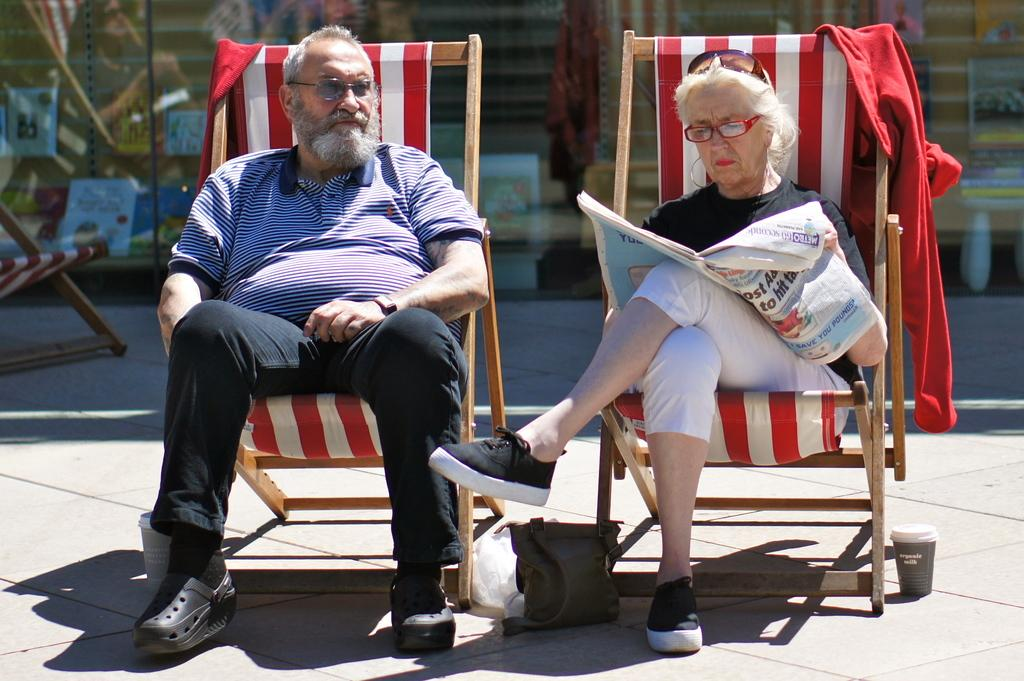How many people are present in the image? There are two people in the image, a man and a woman. What are the man and woman doing in the image? Both the man and woman are sitting on chairs. What can be seen in the background of the image? There is a wall in the background of the image, and there are posters on the wall. What addition problem can be solved using the numbers on the posters in the image? There is no information about numbers or addition problems on the posters in the image, so it is not possible to answer that question. 